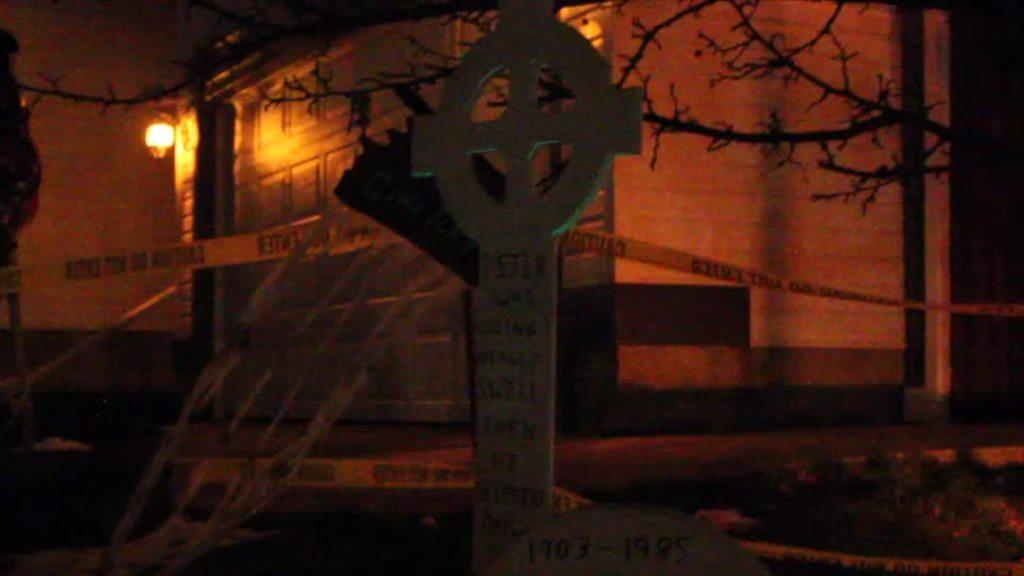What can be seen in the image that represents a sign or mark? There is a symbol in the image. What type of barrier is visible in the image? There is a fence in the image. What type of vegetation can be seen in the image? Dry tree branches are present in the image. What type of structure is visible in the image? There is a building in the image. What feature can be seen on the building in the image? The building has a light on the left side. What type of prison is depicted in the image? There is no prison present in the image. What type of base is shown in the image? There is no base present in the image. 